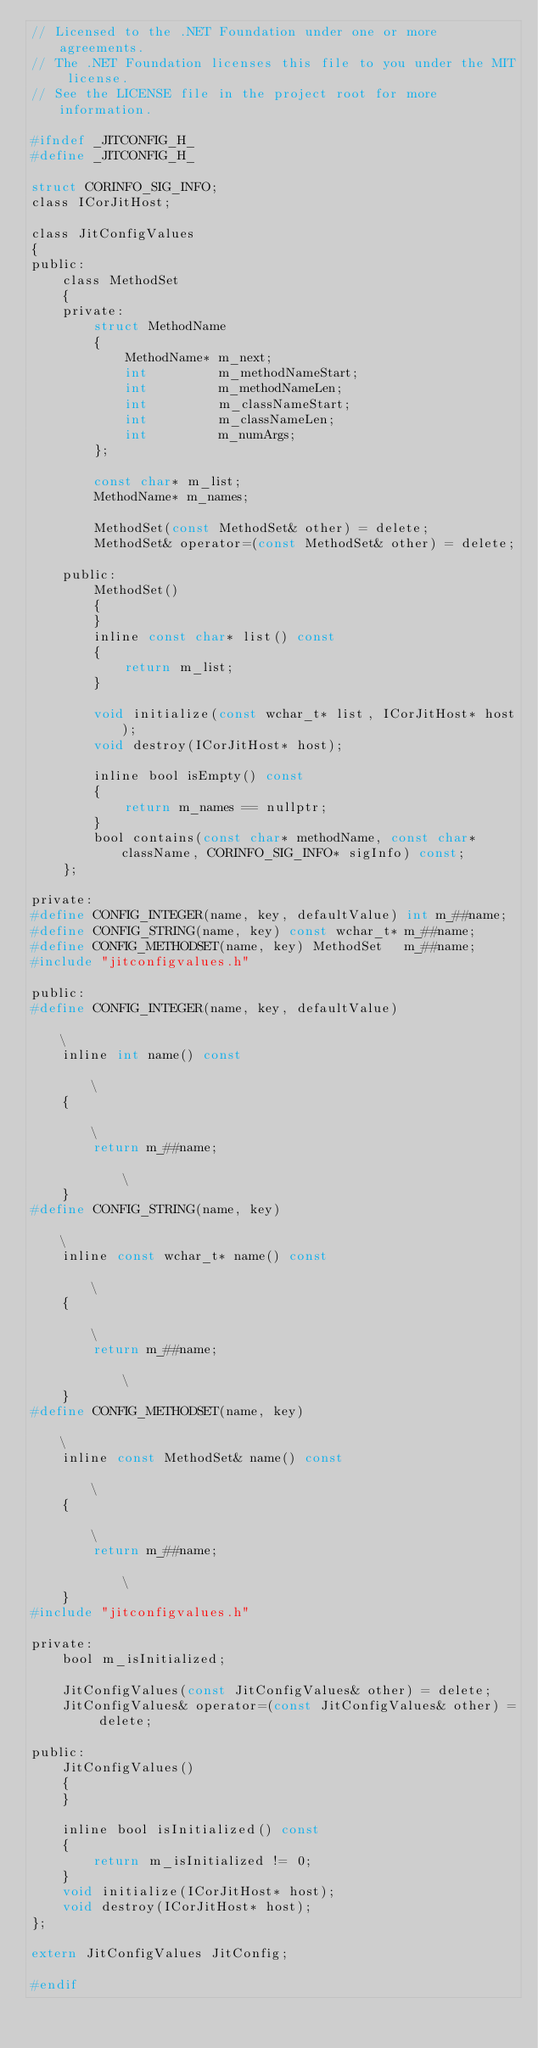Convert code to text. <code><loc_0><loc_0><loc_500><loc_500><_C_>// Licensed to the .NET Foundation under one or more agreements.
// The .NET Foundation licenses this file to you under the MIT license.
// See the LICENSE file in the project root for more information.

#ifndef _JITCONFIG_H_
#define _JITCONFIG_H_

struct CORINFO_SIG_INFO;
class ICorJitHost;

class JitConfigValues
{
public:
    class MethodSet
    {
    private:
        struct MethodName
        {
            MethodName* m_next;
            int         m_methodNameStart;
            int         m_methodNameLen;
            int         m_classNameStart;
            int         m_classNameLen;
            int         m_numArgs;
        };

        const char* m_list;
        MethodName* m_names;

        MethodSet(const MethodSet& other) = delete;
        MethodSet& operator=(const MethodSet& other) = delete;

    public:
        MethodSet()
        {
        }
        inline const char* list() const
        {
            return m_list;
        }

        void initialize(const wchar_t* list, ICorJitHost* host);
        void destroy(ICorJitHost* host);

        inline bool isEmpty() const
        {
            return m_names == nullptr;
        }
        bool contains(const char* methodName, const char* className, CORINFO_SIG_INFO* sigInfo) const;
    };

private:
#define CONFIG_INTEGER(name, key, defaultValue) int m_##name;
#define CONFIG_STRING(name, key) const wchar_t* m_##name;
#define CONFIG_METHODSET(name, key) MethodSet   m_##name;
#include "jitconfigvalues.h"

public:
#define CONFIG_INTEGER(name, key, defaultValue)                                                                        \
    inline int name() const                                                                                            \
    {                                                                                                                  \
        return m_##name;                                                                                               \
    }
#define CONFIG_STRING(name, key)                                                                                       \
    inline const wchar_t* name() const                                                                                 \
    {                                                                                                                  \
        return m_##name;                                                                                               \
    }
#define CONFIG_METHODSET(name, key)                                                                                    \
    inline const MethodSet& name() const                                                                               \
    {                                                                                                                  \
        return m_##name;                                                                                               \
    }
#include "jitconfigvalues.h"

private:
    bool m_isInitialized;

    JitConfigValues(const JitConfigValues& other) = delete;
    JitConfigValues& operator=(const JitConfigValues& other) = delete;

public:
    JitConfigValues()
    {
    }

    inline bool isInitialized() const
    {
        return m_isInitialized != 0;
    }
    void initialize(ICorJitHost* host);
    void destroy(ICorJitHost* host);
};

extern JitConfigValues JitConfig;

#endif
</code> 